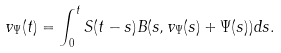<formula> <loc_0><loc_0><loc_500><loc_500>v _ { \Psi } ( t ) = \int _ { 0 } ^ { t } S ( t - s ) B ( s , v _ { \Psi } ( s ) + \Psi ( s ) ) d s .</formula> 